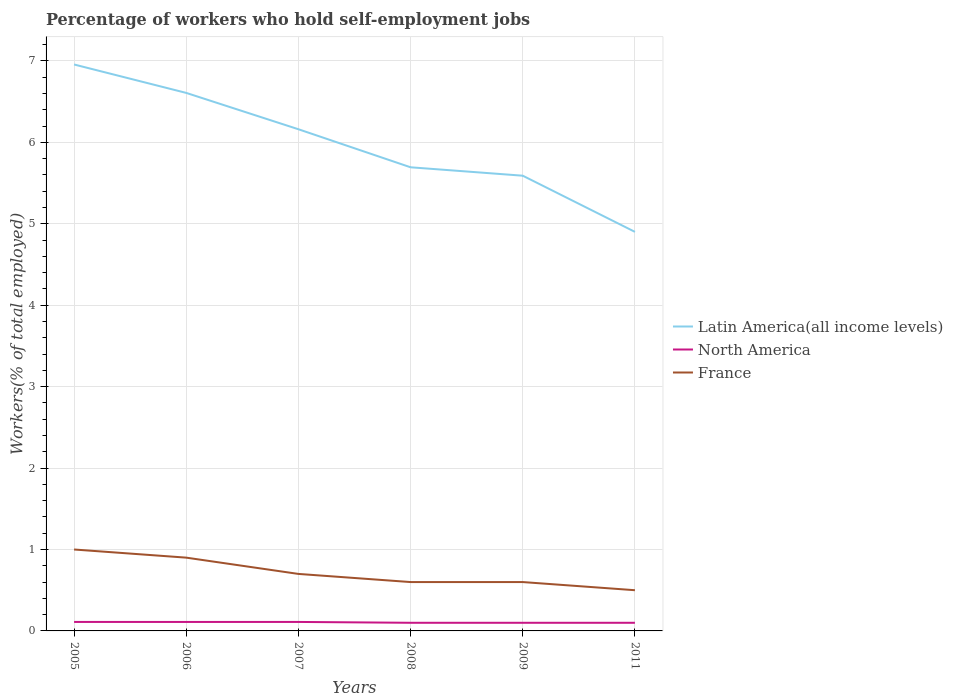Is the number of lines equal to the number of legend labels?
Make the answer very short. Yes. Across all years, what is the maximum percentage of self-employed workers in Latin America(all income levels)?
Ensure brevity in your answer.  4.9. In which year was the percentage of self-employed workers in France maximum?
Offer a very short reply. 2011. What is the total percentage of self-employed workers in France in the graph?
Keep it short and to the point. 0.1. What is the difference between the highest and the second highest percentage of self-employed workers in Latin America(all income levels)?
Offer a very short reply. 2.06. Is the percentage of self-employed workers in Latin America(all income levels) strictly greater than the percentage of self-employed workers in North America over the years?
Provide a succinct answer. No. How many lines are there?
Your answer should be compact. 3. How many years are there in the graph?
Your answer should be compact. 6. Are the values on the major ticks of Y-axis written in scientific E-notation?
Provide a succinct answer. No. Does the graph contain any zero values?
Your response must be concise. No. Where does the legend appear in the graph?
Provide a succinct answer. Center right. How many legend labels are there?
Give a very brief answer. 3. How are the legend labels stacked?
Make the answer very short. Vertical. What is the title of the graph?
Offer a terse response. Percentage of workers who hold self-employment jobs. What is the label or title of the X-axis?
Provide a short and direct response. Years. What is the label or title of the Y-axis?
Offer a terse response. Workers(% of total employed). What is the Workers(% of total employed) in Latin America(all income levels) in 2005?
Your response must be concise. 6.96. What is the Workers(% of total employed) in North America in 2005?
Keep it short and to the point. 0.11. What is the Workers(% of total employed) in France in 2005?
Give a very brief answer. 1. What is the Workers(% of total employed) of Latin America(all income levels) in 2006?
Provide a succinct answer. 6.61. What is the Workers(% of total employed) of North America in 2006?
Offer a terse response. 0.11. What is the Workers(% of total employed) in France in 2006?
Ensure brevity in your answer.  0.9. What is the Workers(% of total employed) of Latin America(all income levels) in 2007?
Give a very brief answer. 6.16. What is the Workers(% of total employed) of North America in 2007?
Provide a short and direct response. 0.11. What is the Workers(% of total employed) of France in 2007?
Your answer should be very brief. 0.7. What is the Workers(% of total employed) of Latin America(all income levels) in 2008?
Offer a very short reply. 5.69. What is the Workers(% of total employed) of North America in 2008?
Offer a terse response. 0.1. What is the Workers(% of total employed) in France in 2008?
Your answer should be compact. 0.6. What is the Workers(% of total employed) of Latin America(all income levels) in 2009?
Make the answer very short. 5.59. What is the Workers(% of total employed) in North America in 2009?
Offer a terse response. 0.1. What is the Workers(% of total employed) in France in 2009?
Make the answer very short. 0.6. What is the Workers(% of total employed) in Latin America(all income levels) in 2011?
Your answer should be very brief. 4.9. What is the Workers(% of total employed) in North America in 2011?
Keep it short and to the point. 0.1. Across all years, what is the maximum Workers(% of total employed) of Latin America(all income levels)?
Ensure brevity in your answer.  6.96. Across all years, what is the maximum Workers(% of total employed) of North America?
Offer a terse response. 0.11. Across all years, what is the minimum Workers(% of total employed) in Latin America(all income levels)?
Your answer should be compact. 4.9. Across all years, what is the minimum Workers(% of total employed) of North America?
Offer a very short reply. 0.1. Across all years, what is the minimum Workers(% of total employed) of France?
Give a very brief answer. 0.5. What is the total Workers(% of total employed) in Latin America(all income levels) in the graph?
Provide a succinct answer. 35.91. What is the total Workers(% of total employed) in North America in the graph?
Give a very brief answer. 0.63. What is the difference between the Workers(% of total employed) in Latin America(all income levels) in 2005 and that in 2006?
Make the answer very short. 0.35. What is the difference between the Workers(% of total employed) in France in 2005 and that in 2006?
Give a very brief answer. 0.1. What is the difference between the Workers(% of total employed) in Latin America(all income levels) in 2005 and that in 2007?
Your answer should be compact. 0.8. What is the difference between the Workers(% of total employed) in North America in 2005 and that in 2007?
Keep it short and to the point. -0. What is the difference between the Workers(% of total employed) in Latin America(all income levels) in 2005 and that in 2008?
Offer a very short reply. 1.26. What is the difference between the Workers(% of total employed) of North America in 2005 and that in 2008?
Ensure brevity in your answer.  0.01. What is the difference between the Workers(% of total employed) of France in 2005 and that in 2008?
Make the answer very short. 0.4. What is the difference between the Workers(% of total employed) in Latin America(all income levels) in 2005 and that in 2009?
Keep it short and to the point. 1.37. What is the difference between the Workers(% of total employed) in North America in 2005 and that in 2009?
Ensure brevity in your answer.  0.01. What is the difference between the Workers(% of total employed) in France in 2005 and that in 2009?
Keep it short and to the point. 0.4. What is the difference between the Workers(% of total employed) in Latin America(all income levels) in 2005 and that in 2011?
Keep it short and to the point. 2.06. What is the difference between the Workers(% of total employed) in North America in 2005 and that in 2011?
Make the answer very short. 0.01. What is the difference between the Workers(% of total employed) in France in 2005 and that in 2011?
Your answer should be very brief. 0.5. What is the difference between the Workers(% of total employed) of Latin America(all income levels) in 2006 and that in 2007?
Provide a succinct answer. 0.45. What is the difference between the Workers(% of total employed) in North America in 2006 and that in 2007?
Offer a terse response. -0. What is the difference between the Workers(% of total employed) in Latin America(all income levels) in 2006 and that in 2008?
Provide a short and direct response. 0.91. What is the difference between the Workers(% of total employed) in North America in 2006 and that in 2008?
Offer a very short reply. 0.01. What is the difference between the Workers(% of total employed) of France in 2006 and that in 2008?
Offer a very short reply. 0.3. What is the difference between the Workers(% of total employed) in Latin America(all income levels) in 2006 and that in 2009?
Offer a very short reply. 1.02. What is the difference between the Workers(% of total employed) in North America in 2006 and that in 2009?
Provide a succinct answer. 0.01. What is the difference between the Workers(% of total employed) of Latin America(all income levels) in 2006 and that in 2011?
Your answer should be very brief. 1.71. What is the difference between the Workers(% of total employed) in North America in 2006 and that in 2011?
Your answer should be compact. 0.01. What is the difference between the Workers(% of total employed) in Latin America(all income levels) in 2007 and that in 2008?
Offer a very short reply. 0.47. What is the difference between the Workers(% of total employed) in North America in 2007 and that in 2008?
Make the answer very short. 0.01. What is the difference between the Workers(% of total employed) in Latin America(all income levels) in 2007 and that in 2009?
Ensure brevity in your answer.  0.57. What is the difference between the Workers(% of total employed) in North America in 2007 and that in 2009?
Ensure brevity in your answer.  0.01. What is the difference between the Workers(% of total employed) of France in 2007 and that in 2009?
Your answer should be compact. 0.1. What is the difference between the Workers(% of total employed) in Latin America(all income levels) in 2007 and that in 2011?
Ensure brevity in your answer.  1.26. What is the difference between the Workers(% of total employed) of North America in 2007 and that in 2011?
Ensure brevity in your answer.  0.01. What is the difference between the Workers(% of total employed) of France in 2007 and that in 2011?
Ensure brevity in your answer.  0.2. What is the difference between the Workers(% of total employed) in Latin America(all income levels) in 2008 and that in 2009?
Provide a short and direct response. 0.1. What is the difference between the Workers(% of total employed) of North America in 2008 and that in 2009?
Your response must be concise. 0. What is the difference between the Workers(% of total employed) of France in 2008 and that in 2009?
Make the answer very short. 0. What is the difference between the Workers(% of total employed) in Latin America(all income levels) in 2008 and that in 2011?
Your response must be concise. 0.79. What is the difference between the Workers(% of total employed) of Latin America(all income levels) in 2009 and that in 2011?
Provide a short and direct response. 0.69. What is the difference between the Workers(% of total employed) of North America in 2009 and that in 2011?
Provide a short and direct response. 0. What is the difference between the Workers(% of total employed) in France in 2009 and that in 2011?
Make the answer very short. 0.1. What is the difference between the Workers(% of total employed) of Latin America(all income levels) in 2005 and the Workers(% of total employed) of North America in 2006?
Provide a succinct answer. 6.85. What is the difference between the Workers(% of total employed) of Latin America(all income levels) in 2005 and the Workers(% of total employed) of France in 2006?
Offer a terse response. 6.06. What is the difference between the Workers(% of total employed) of North America in 2005 and the Workers(% of total employed) of France in 2006?
Provide a short and direct response. -0.79. What is the difference between the Workers(% of total employed) of Latin America(all income levels) in 2005 and the Workers(% of total employed) of North America in 2007?
Give a very brief answer. 6.85. What is the difference between the Workers(% of total employed) in Latin America(all income levels) in 2005 and the Workers(% of total employed) in France in 2007?
Ensure brevity in your answer.  6.26. What is the difference between the Workers(% of total employed) of North America in 2005 and the Workers(% of total employed) of France in 2007?
Your answer should be very brief. -0.59. What is the difference between the Workers(% of total employed) of Latin America(all income levels) in 2005 and the Workers(% of total employed) of North America in 2008?
Your answer should be very brief. 6.86. What is the difference between the Workers(% of total employed) in Latin America(all income levels) in 2005 and the Workers(% of total employed) in France in 2008?
Your answer should be compact. 6.36. What is the difference between the Workers(% of total employed) of North America in 2005 and the Workers(% of total employed) of France in 2008?
Make the answer very short. -0.49. What is the difference between the Workers(% of total employed) of Latin America(all income levels) in 2005 and the Workers(% of total employed) of North America in 2009?
Ensure brevity in your answer.  6.86. What is the difference between the Workers(% of total employed) of Latin America(all income levels) in 2005 and the Workers(% of total employed) of France in 2009?
Make the answer very short. 6.36. What is the difference between the Workers(% of total employed) in North America in 2005 and the Workers(% of total employed) in France in 2009?
Ensure brevity in your answer.  -0.49. What is the difference between the Workers(% of total employed) of Latin America(all income levels) in 2005 and the Workers(% of total employed) of North America in 2011?
Provide a succinct answer. 6.86. What is the difference between the Workers(% of total employed) in Latin America(all income levels) in 2005 and the Workers(% of total employed) in France in 2011?
Offer a very short reply. 6.46. What is the difference between the Workers(% of total employed) of North America in 2005 and the Workers(% of total employed) of France in 2011?
Make the answer very short. -0.39. What is the difference between the Workers(% of total employed) in Latin America(all income levels) in 2006 and the Workers(% of total employed) in North America in 2007?
Your response must be concise. 6.5. What is the difference between the Workers(% of total employed) of Latin America(all income levels) in 2006 and the Workers(% of total employed) of France in 2007?
Provide a succinct answer. 5.91. What is the difference between the Workers(% of total employed) in North America in 2006 and the Workers(% of total employed) in France in 2007?
Your answer should be very brief. -0.59. What is the difference between the Workers(% of total employed) in Latin America(all income levels) in 2006 and the Workers(% of total employed) in North America in 2008?
Make the answer very short. 6.51. What is the difference between the Workers(% of total employed) in Latin America(all income levels) in 2006 and the Workers(% of total employed) in France in 2008?
Provide a succinct answer. 6.01. What is the difference between the Workers(% of total employed) of North America in 2006 and the Workers(% of total employed) of France in 2008?
Provide a succinct answer. -0.49. What is the difference between the Workers(% of total employed) of Latin America(all income levels) in 2006 and the Workers(% of total employed) of North America in 2009?
Provide a short and direct response. 6.51. What is the difference between the Workers(% of total employed) in Latin America(all income levels) in 2006 and the Workers(% of total employed) in France in 2009?
Keep it short and to the point. 6.01. What is the difference between the Workers(% of total employed) in North America in 2006 and the Workers(% of total employed) in France in 2009?
Make the answer very short. -0.49. What is the difference between the Workers(% of total employed) in Latin America(all income levels) in 2006 and the Workers(% of total employed) in North America in 2011?
Make the answer very short. 6.51. What is the difference between the Workers(% of total employed) in Latin America(all income levels) in 2006 and the Workers(% of total employed) in France in 2011?
Offer a terse response. 6.11. What is the difference between the Workers(% of total employed) of North America in 2006 and the Workers(% of total employed) of France in 2011?
Offer a terse response. -0.39. What is the difference between the Workers(% of total employed) of Latin America(all income levels) in 2007 and the Workers(% of total employed) of North America in 2008?
Your answer should be very brief. 6.06. What is the difference between the Workers(% of total employed) in Latin America(all income levels) in 2007 and the Workers(% of total employed) in France in 2008?
Your response must be concise. 5.56. What is the difference between the Workers(% of total employed) in North America in 2007 and the Workers(% of total employed) in France in 2008?
Provide a short and direct response. -0.49. What is the difference between the Workers(% of total employed) in Latin America(all income levels) in 2007 and the Workers(% of total employed) in North America in 2009?
Give a very brief answer. 6.06. What is the difference between the Workers(% of total employed) in Latin America(all income levels) in 2007 and the Workers(% of total employed) in France in 2009?
Your answer should be compact. 5.56. What is the difference between the Workers(% of total employed) of North America in 2007 and the Workers(% of total employed) of France in 2009?
Offer a very short reply. -0.49. What is the difference between the Workers(% of total employed) of Latin America(all income levels) in 2007 and the Workers(% of total employed) of North America in 2011?
Ensure brevity in your answer.  6.06. What is the difference between the Workers(% of total employed) in Latin America(all income levels) in 2007 and the Workers(% of total employed) in France in 2011?
Offer a terse response. 5.66. What is the difference between the Workers(% of total employed) in North America in 2007 and the Workers(% of total employed) in France in 2011?
Offer a terse response. -0.39. What is the difference between the Workers(% of total employed) of Latin America(all income levels) in 2008 and the Workers(% of total employed) of North America in 2009?
Your answer should be compact. 5.59. What is the difference between the Workers(% of total employed) in Latin America(all income levels) in 2008 and the Workers(% of total employed) in France in 2009?
Ensure brevity in your answer.  5.09. What is the difference between the Workers(% of total employed) in North America in 2008 and the Workers(% of total employed) in France in 2009?
Your answer should be compact. -0.5. What is the difference between the Workers(% of total employed) in Latin America(all income levels) in 2008 and the Workers(% of total employed) in North America in 2011?
Ensure brevity in your answer.  5.59. What is the difference between the Workers(% of total employed) in Latin America(all income levels) in 2008 and the Workers(% of total employed) in France in 2011?
Keep it short and to the point. 5.19. What is the difference between the Workers(% of total employed) of North America in 2008 and the Workers(% of total employed) of France in 2011?
Your response must be concise. -0.4. What is the difference between the Workers(% of total employed) of Latin America(all income levels) in 2009 and the Workers(% of total employed) of North America in 2011?
Offer a terse response. 5.49. What is the difference between the Workers(% of total employed) of Latin America(all income levels) in 2009 and the Workers(% of total employed) of France in 2011?
Ensure brevity in your answer.  5.09. What is the difference between the Workers(% of total employed) in North America in 2009 and the Workers(% of total employed) in France in 2011?
Your response must be concise. -0.4. What is the average Workers(% of total employed) of Latin America(all income levels) per year?
Provide a short and direct response. 5.99. What is the average Workers(% of total employed) of North America per year?
Ensure brevity in your answer.  0.11. What is the average Workers(% of total employed) in France per year?
Keep it short and to the point. 0.72. In the year 2005, what is the difference between the Workers(% of total employed) in Latin America(all income levels) and Workers(% of total employed) in North America?
Give a very brief answer. 6.85. In the year 2005, what is the difference between the Workers(% of total employed) of Latin America(all income levels) and Workers(% of total employed) of France?
Ensure brevity in your answer.  5.96. In the year 2005, what is the difference between the Workers(% of total employed) of North America and Workers(% of total employed) of France?
Provide a succinct answer. -0.89. In the year 2006, what is the difference between the Workers(% of total employed) of Latin America(all income levels) and Workers(% of total employed) of North America?
Offer a terse response. 6.5. In the year 2006, what is the difference between the Workers(% of total employed) of Latin America(all income levels) and Workers(% of total employed) of France?
Offer a terse response. 5.71. In the year 2006, what is the difference between the Workers(% of total employed) of North America and Workers(% of total employed) of France?
Your answer should be compact. -0.79. In the year 2007, what is the difference between the Workers(% of total employed) of Latin America(all income levels) and Workers(% of total employed) of North America?
Ensure brevity in your answer.  6.05. In the year 2007, what is the difference between the Workers(% of total employed) of Latin America(all income levels) and Workers(% of total employed) of France?
Keep it short and to the point. 5.46. In the year 2007, what is the difference between the Workers(% of total employed) in North America and Workers(% of total employed) in France?
Your answer should be compact. -0.59. In the year 2008, what is the difference between the Workers(% of total employed) in Latin America(all income levels) and Workers(% of total employed) in North America?
Offer a terse response. 5.59. In the year 2008, what is the difference between the Workers(% of total employed) of Latin America(all income levels) and Workers(% of total employed) of France?
Provide a succinct answer. 5.09. In the year 2008, what is the difference between the Workers(% of total employed) in North America and Workers(% of total employed) in France?
Provide a succinct answer. -0.5. In the year 2009, what is the difference between the Workers(% of total employed) of Latin America(all income levels) and Workers(% of total employed) of North America?
Provide a short and direct response. 5.49. In the year 2009, what is the difference between the Workers(% of total employed) in Latin America(all income levels) and Workers(% of total employed) in France?
Your answer should be compact. 4.99. In the year 2009, what is the difference between the Workers(% of total employed) in North America and Workers(% of total employed) in France?
Your response must be concise. -0.5. In the year 2011, what is the difference between the Workers(% of total employed) of Latin America(all income levels) and Workers(% of total employed) of North America?
Your answer should be very brief. 4.8. In the year 2011, what is the difference between the Workers(% of total employed) in Latin America(all income levels) and Workers(% of total employed) in France?
Ensure brevity in your answer.  4.4. What is the ratio of the Workers(% of total employed) in Latin America(all income levels) in 2005 to that in 2006?
Your answer should be compact. 1.05. What is the ratio of the Workers(% of total employed) of Latin America(all income levels) in 2005 to that in 2007?
Make the answer very short. 1.13. What is the ratio of the Workers(% of total employed) of France in 2005 to that in 2007?
Make the answer very short. 1.43. What is the ratio of the Workers(% of total employed) of Latin America(all income levels) in 2005 to that in 2008?
Provide a short and direct response. 1.22. What is the ratio of the Workers(% of total employed) in North America in 2005 to that in 2008?
Your answer should be very brief. 1.1. What is the ratio of the Workers(% of total employed) in Latin America(all income levels) in 2005 to that in 2009?
Your response must be concise. 1.24. What is the ratio of the Workers(% of total employed) in North America in 2005 to that in 2009?
Provide a succinct answer. 1.1. What is the ratio of the Workers(% of total employed) in Latin America(all income levels) in 2005 to that in 2011?
Your response must be concise. 1.42. What is the ratio of the Workers(% of total employed) in North America in 2005 to that in 2011?
Make the answer very short. 1.1. What is the ratio of the Workers(% of total employed) of France in 2005 to that in 2011?
Ensure brevity in your answer.  2. What is the ratio of the Workers(% of total employed) of Latin America(all income levels) in 2006 to that in 2007?
Your answer should be compact. 1.07. What is the ratio of the Workers(% of total employed) in France in 2006 to that in 2007?
Ensure brevity in your answer.  1.29. What is the ratio of the Workers(% of total employed) in Latin America(all income levels) in 2006 to that in 2008?
Provide a short and direct response. 1.16. What is the ratio of the Workers(% of total employed) in North America in 2006 to that in 2008?
Offer a very short reply. 1.1. What is the ratio of the Workers(% of total employed) in France in 2006 to that in 2008?
Provide a short and direct response. 1.5. What is the ratio of the Workers(% of total employed) of Latin America(all income levels) in 2006 to that in 2009?
Your answer should be compact. 1.18. What is the ratio of the Workers(% of total employed) of North America in 2006 to that in 2009?
Keep it short and to the point. 1.1. What is the ratio of the Workers(% of total employed) in Latin America(all income levels) in 2006 to that in 2011?
Offer a terse response. 1.35. What is the ratio of the Workers(% of total employed) in North America in 2006 to that in 2011?
Your response must be concise. 1.1. What is the ratio of the Workers(% of total employed) in Latin America(all income levels) in 2007 to that in 2008?
Offer a terse response. 1.08. What is the ratio of the Workers(% of total employed) in North America in 2007 to that in 2008?
Make the answer very short. 1.1. What is the ratio of the Workers(% of total employed) in Latin America(all income levels) in 2007 to that in 2009?
Provide a succinct answer. 1.1. What is the ratio of the Workers(% of total employed) in North America in 2007 to that in 2009?
Make the answer very short. 1.1. What is the ratio of the Workers(% of total employed) of Latin America(all income levels) in 2007 to that in 2011?
Your response must be concise. 1.26. What is the ratio of the Workers(% of total employed) of North America in 2007 to that in 2011?
Keep it short and to the point. 1.1. What is the ratio of the Workers(% of total employed) of France in 2007 to that in 2011?
Your answer should be very brief. 1.4. What is the ratio of the Workers(% of total employed) in Latin America(all income levels) in 2008 to that in 2009?
Offer a very short reply. 1.02. What is the ratio of the Workers(% of total employed) of Latin America(all income levels) in 2008 to that in 2011?
Ensure brevity in your answer.  1.16. What is the ratio of the Workers(% of total employed) in France in 2008 to that in 2011?
Ensure brevity in your answer.  1.2. What is the ratio of the Workers(% of total employed) of Latin America(all income levels) in 2009 to that in 2011?
Your response must be concise. 1.14. What is the difference between the highest and the second highest Workers(% of total employed) of Latin America(all income levels)?
Your answer should be very brief. 0.35. What is the difference between the highest and the second highest Workers(% of total employed) of North America?
Offer a very short reply. 0. What is the difference between the highest and the second highest Workers(% of total employed) in France?
Keep it short and to the point. 0.1. What is the difference between the highest and the lowest Workers(% of total employed) of Latin America(all income levels)?
Give a very brief answer. 2.06. What is the difference between the highest and the lowest Workers(% of total employed) in North America?
Your answer should be compact. 0.01. 